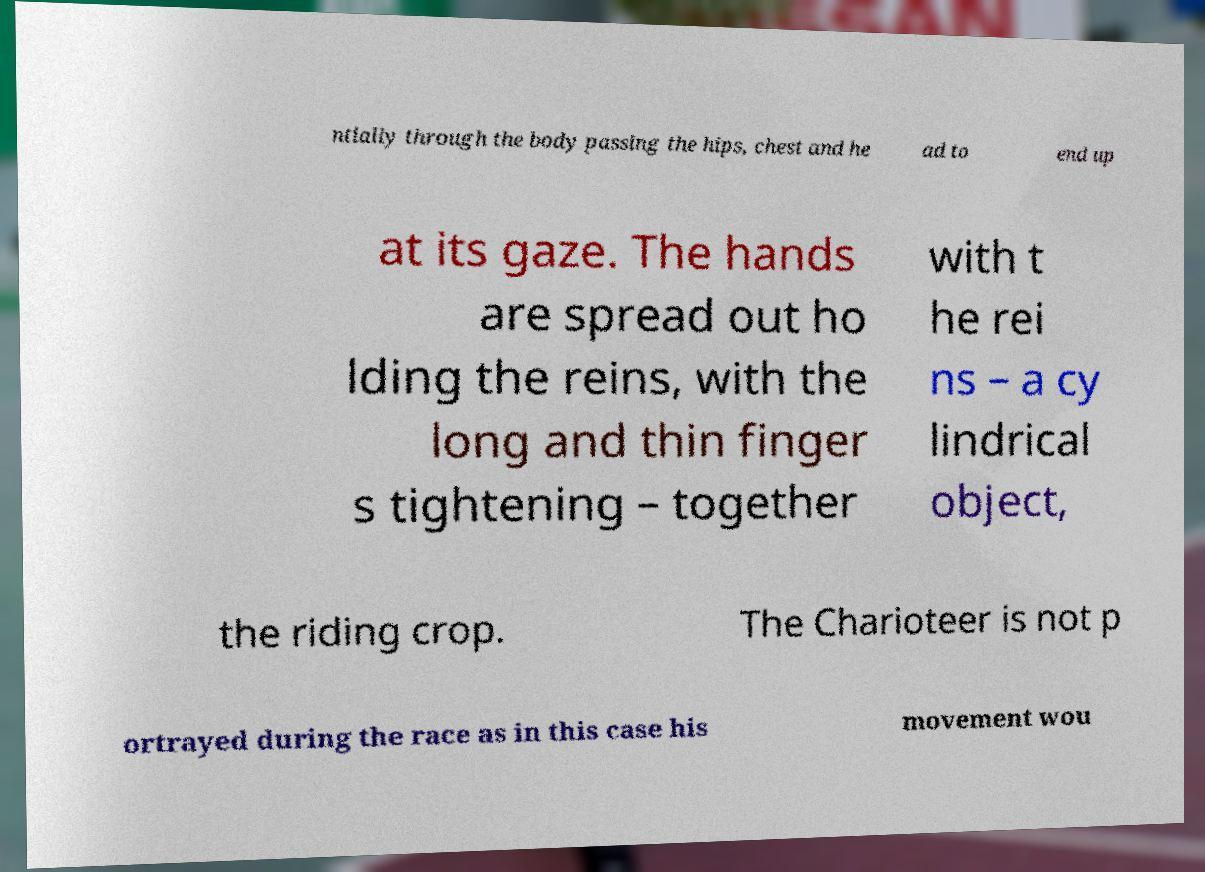What messages or text are displayed in this image? I need them in a readable, typed format. ntially through the body passing the hips, chest and he ad to end up at its gaze. The hands are spread out ho lding the reins, with the long and thin finger s tightening – together with t he rei ns – a cy lindrical object, the riding crop. The Charioteer is not p ortrayed during the race as in this case his movement wou 